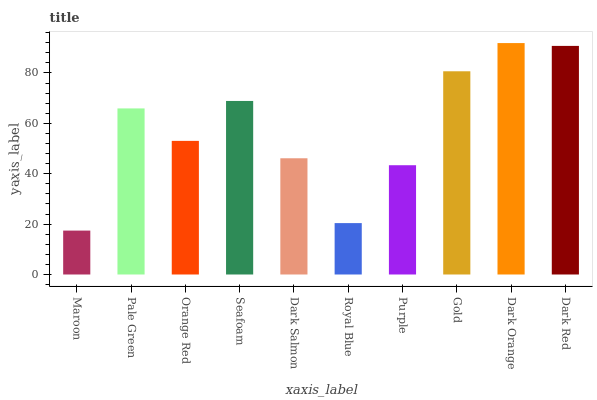Is Maroon the minimum?
Answer yes or no. Yes. Is Dark Orange the maximum?
Answer yes or no. Yes. Is Pale Green the minimum?
Answer yes or no. No. Is Pale Green the maximum?
Answer yes or no. No. Is Pale Green greater than Maroon?
Answer yes or no. Yes. Is Maroon less than Pale Green?
Answer yes or no. Yes. Is Maroon greater than Pale Green?
Answer yes or no. No. Is Pale Green less than Maroon?
Answer yes or no. No. Is Pale Green the high median?
Answer yes or no. Yes. Is Orange Red the low median?
Answer yes or no. Yes. Is Dark Orange the high median?
Answer yes or no. No. Is Seafoam the low median?
Answer yes or no. No. 